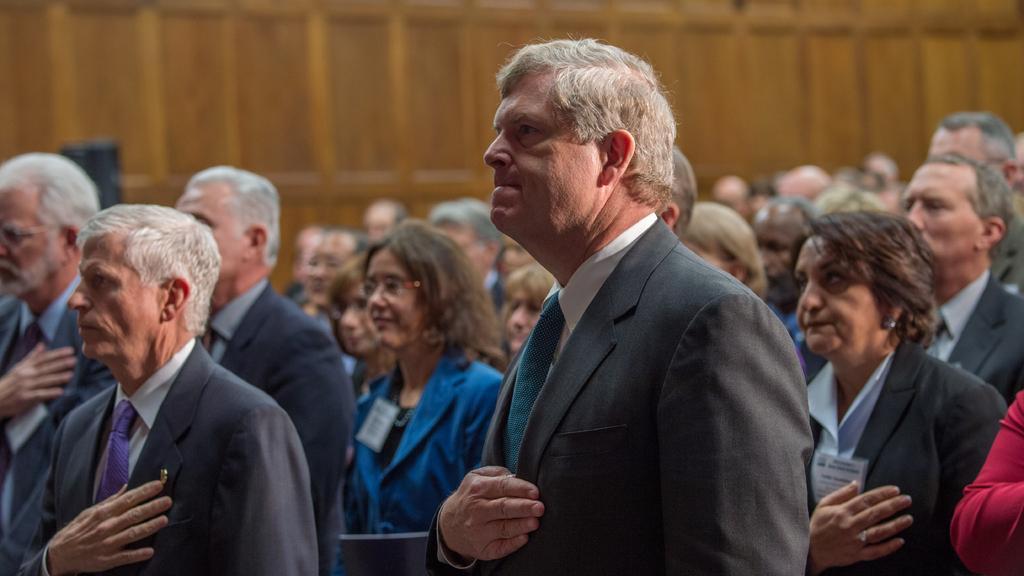How would you summarize this image in a sentence or two? In this image there are a group of people who are standing and all of them are putting hands on their hearts, in the background there is a wooden wall. 